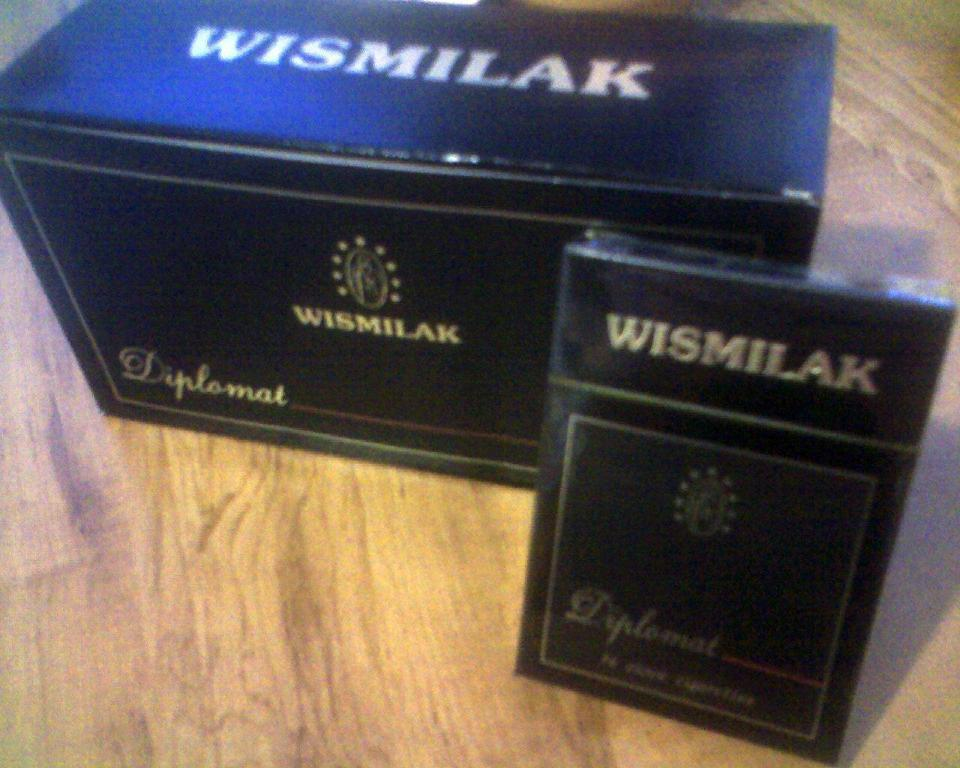<image>
Provide a brief description of the given image. package of wismilak in front of larger box of wismilak on wooden surface 